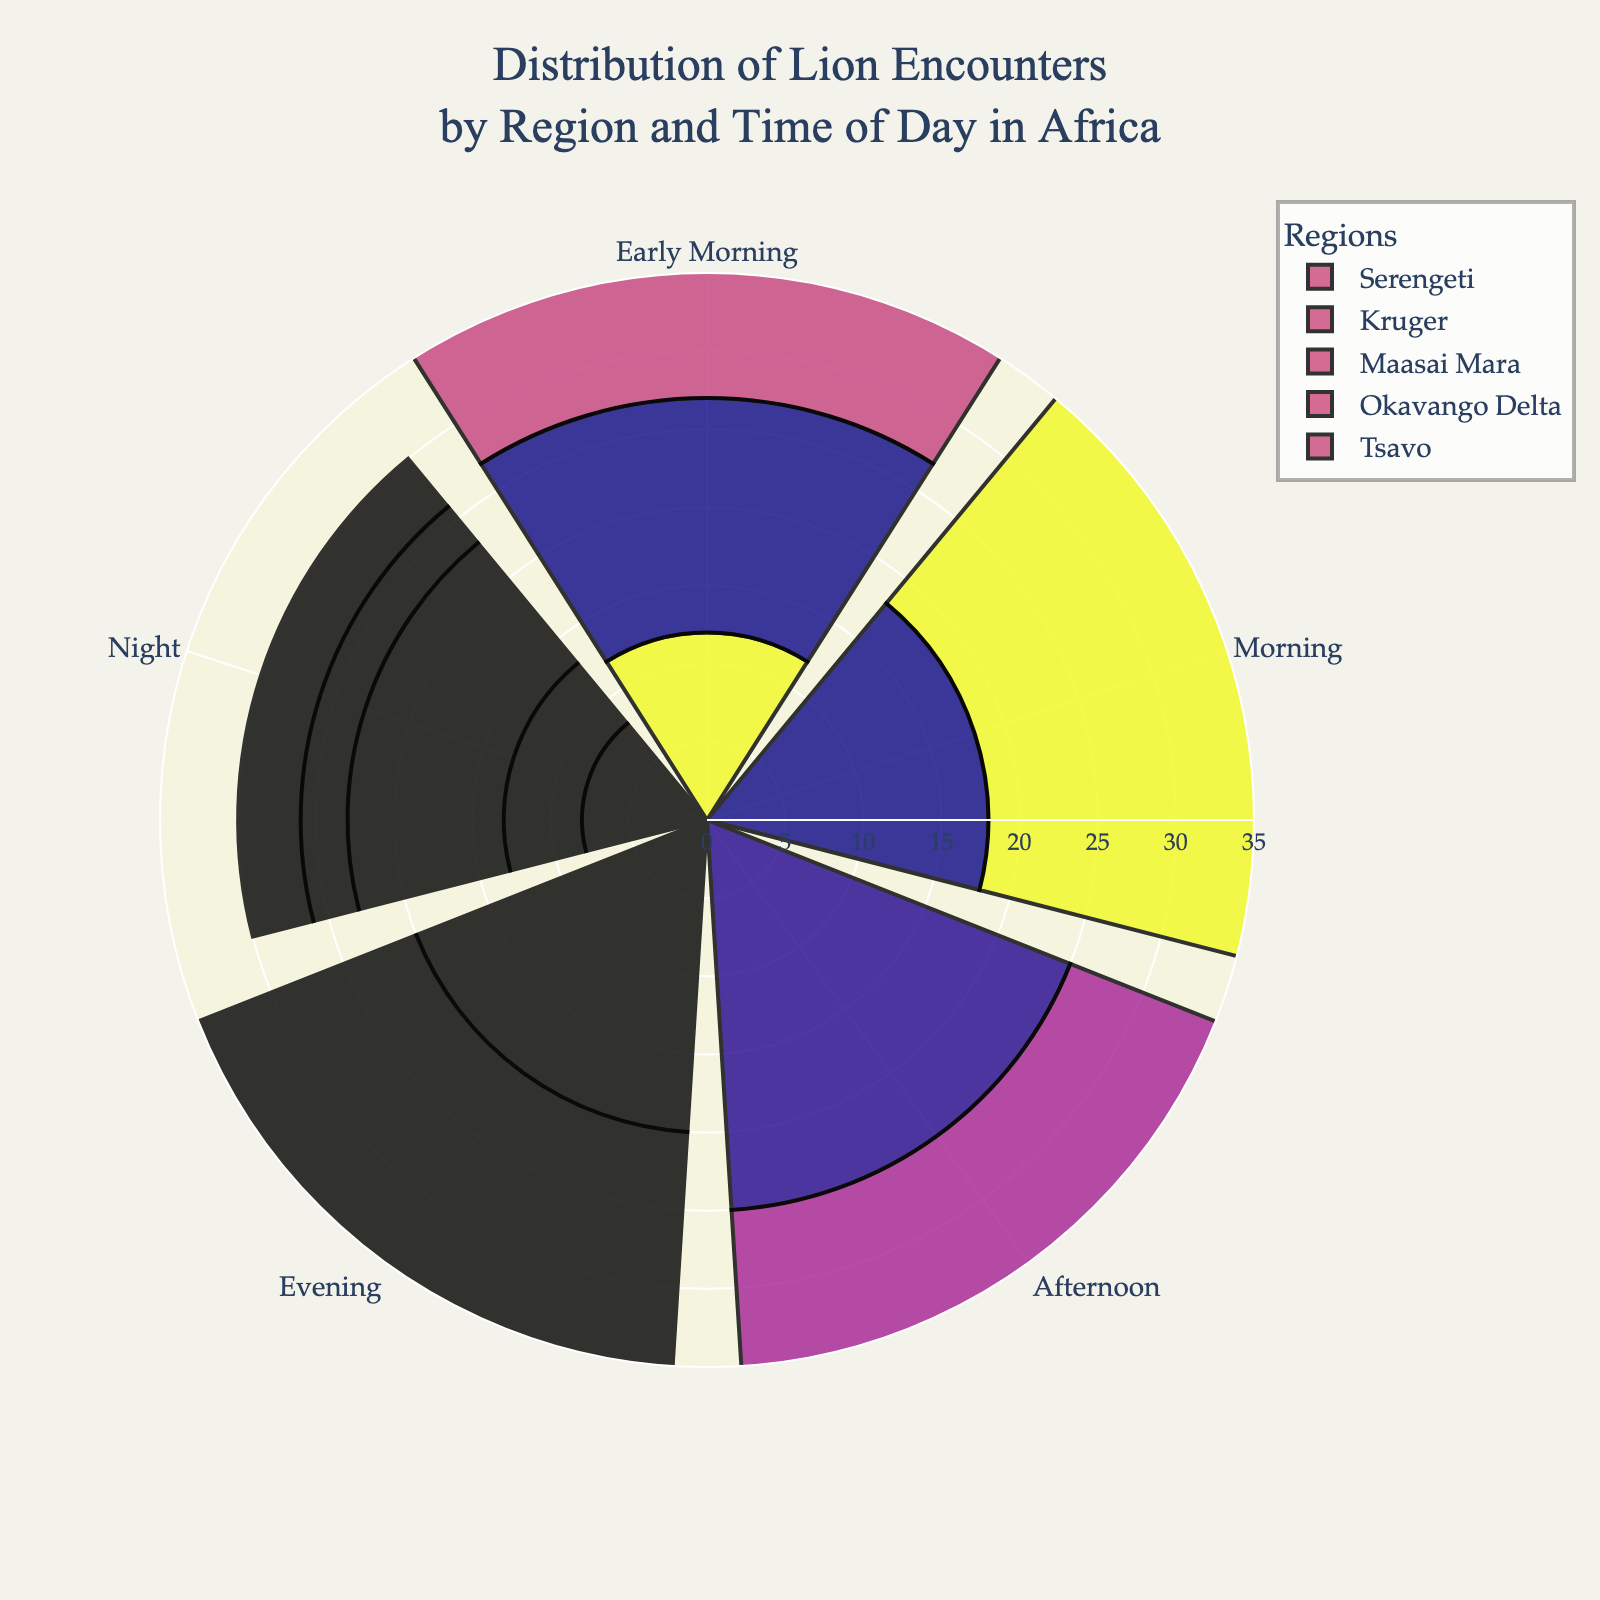How many regions are displayed in the figure? The figure separates the lion encounters by distinct regions. By looking at the different colored segments, we can count the unique regions featured.
Answer: 5 What is the maximum number of encounters in the Serengeti region and at what time? In the Serengeti region, identify the segment with the highest value by viewing the radial axis listings. This represents the maximum encounters.
Answer: 25, Afternoon Which region has the highest number of encounters during the Evening? Compare the length of the polar segments corresponding to the Evening time for all regions and identify the longest segment.
Answer: Kruger What is the total number of encounters in the Maasai Mara region? To get the total, sum up all the radial values for Maasai Mara across different times of the day: 10 + 16 + 24 + 26 + 10.
Answer: 86 How do the Kruger encounters in the Morning compare to those in the Night? By comparing the lengths of the segments for Morning and Night in Kruger, we can see which is longer and thus determine which has more encounters.
Answer: Morning encounters are greater than Night encounters What is the average number of encounters across all regions in the Afternoon? Sum the Afternoon values for each region and divide by the number of regions: (25 + 28 + 24 + 20 + 18) / 5.
Answer: 23 Is the distribution of lion encounters more spread out across different times of day in the Serengeti or Okavango Delta? Compare the variance in encounter values across different times of the day for both regions. Higher variance means more spread out.
Answer: Serengeti Which time of day generally has the lowest number of encounters across all regions? By checking the lengths of the segments for all regions at different times of the day, identify the time with the shortest lengths.
Answer: Night What is the difference in the number of encounters between the Serengeti and Tsavo in the Evening? Subtract the Tsavo Evening encounters from the Serengeti Evening encounters to find the difference: 20 - 14.
Answer: 6 During which time of day does the Maasai Mara have more encounters compared to the Okavango Delta? For each time of day, compare the segment lengths for Maasai Mara and the Okavango Delta, noting when Maasai Mara has more.
Answer: All times of the day 